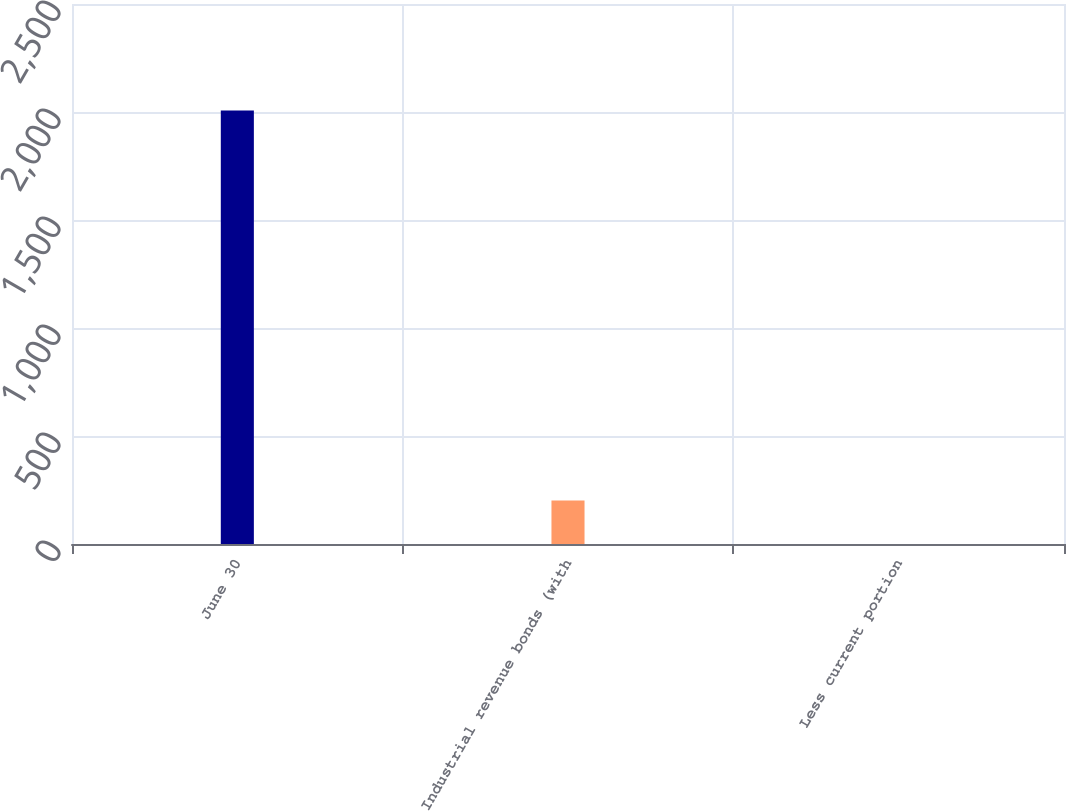<chart> <loc_0><loc_0><loc_500><loc_500><bar_chart><fcel>June 30<fcel>Industrial revenue bonds (with<fcel>Less current portion<nl><fcel>2007<fcel>200.88<fcel>0.2<nl></chart> 